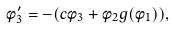Convert formula to latex. <formula><loc_0><loc_0><loc_500><loc_500>\phi _ { 3 } ^ { \prime } = - ( c \phi _ { 3 } + \phi _ { 2 } g ( \phi _ { 1 } ) ) ,</formula> 